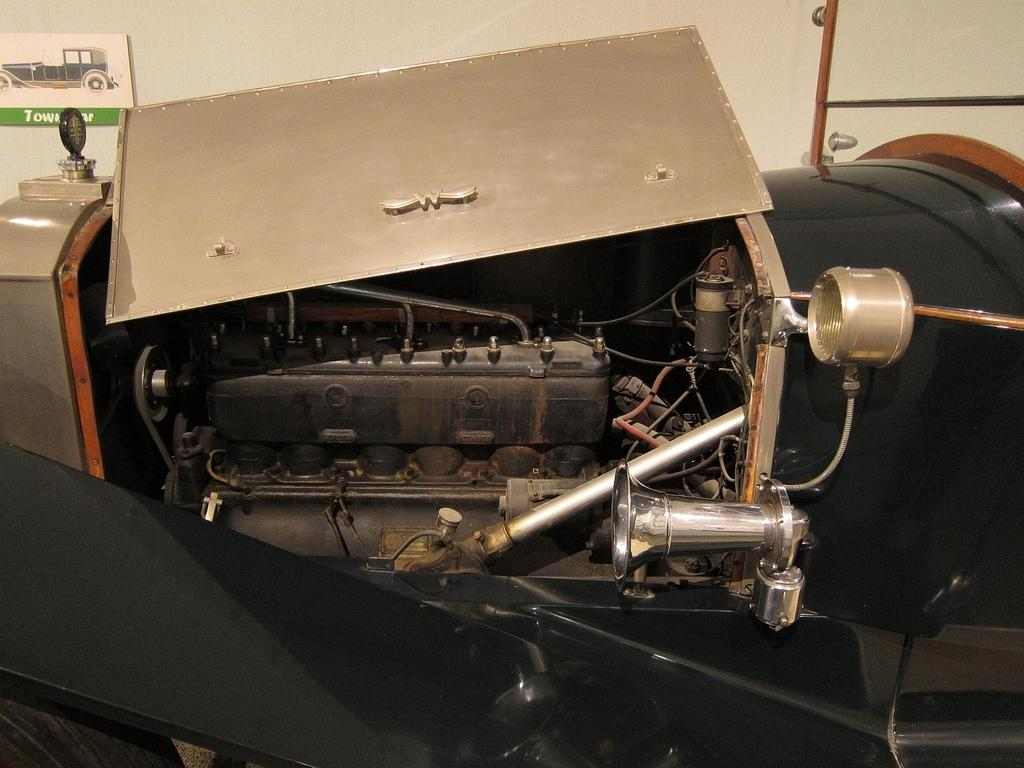What is the main subject in the center of the image? There is an electrical equipment in the center of the image. What can be seen in the background of the image? There is a wall in the background of the image. What type of insect is crawling on the electrical equipment in the image? There is no insect present on the electrical equipment in the image. 